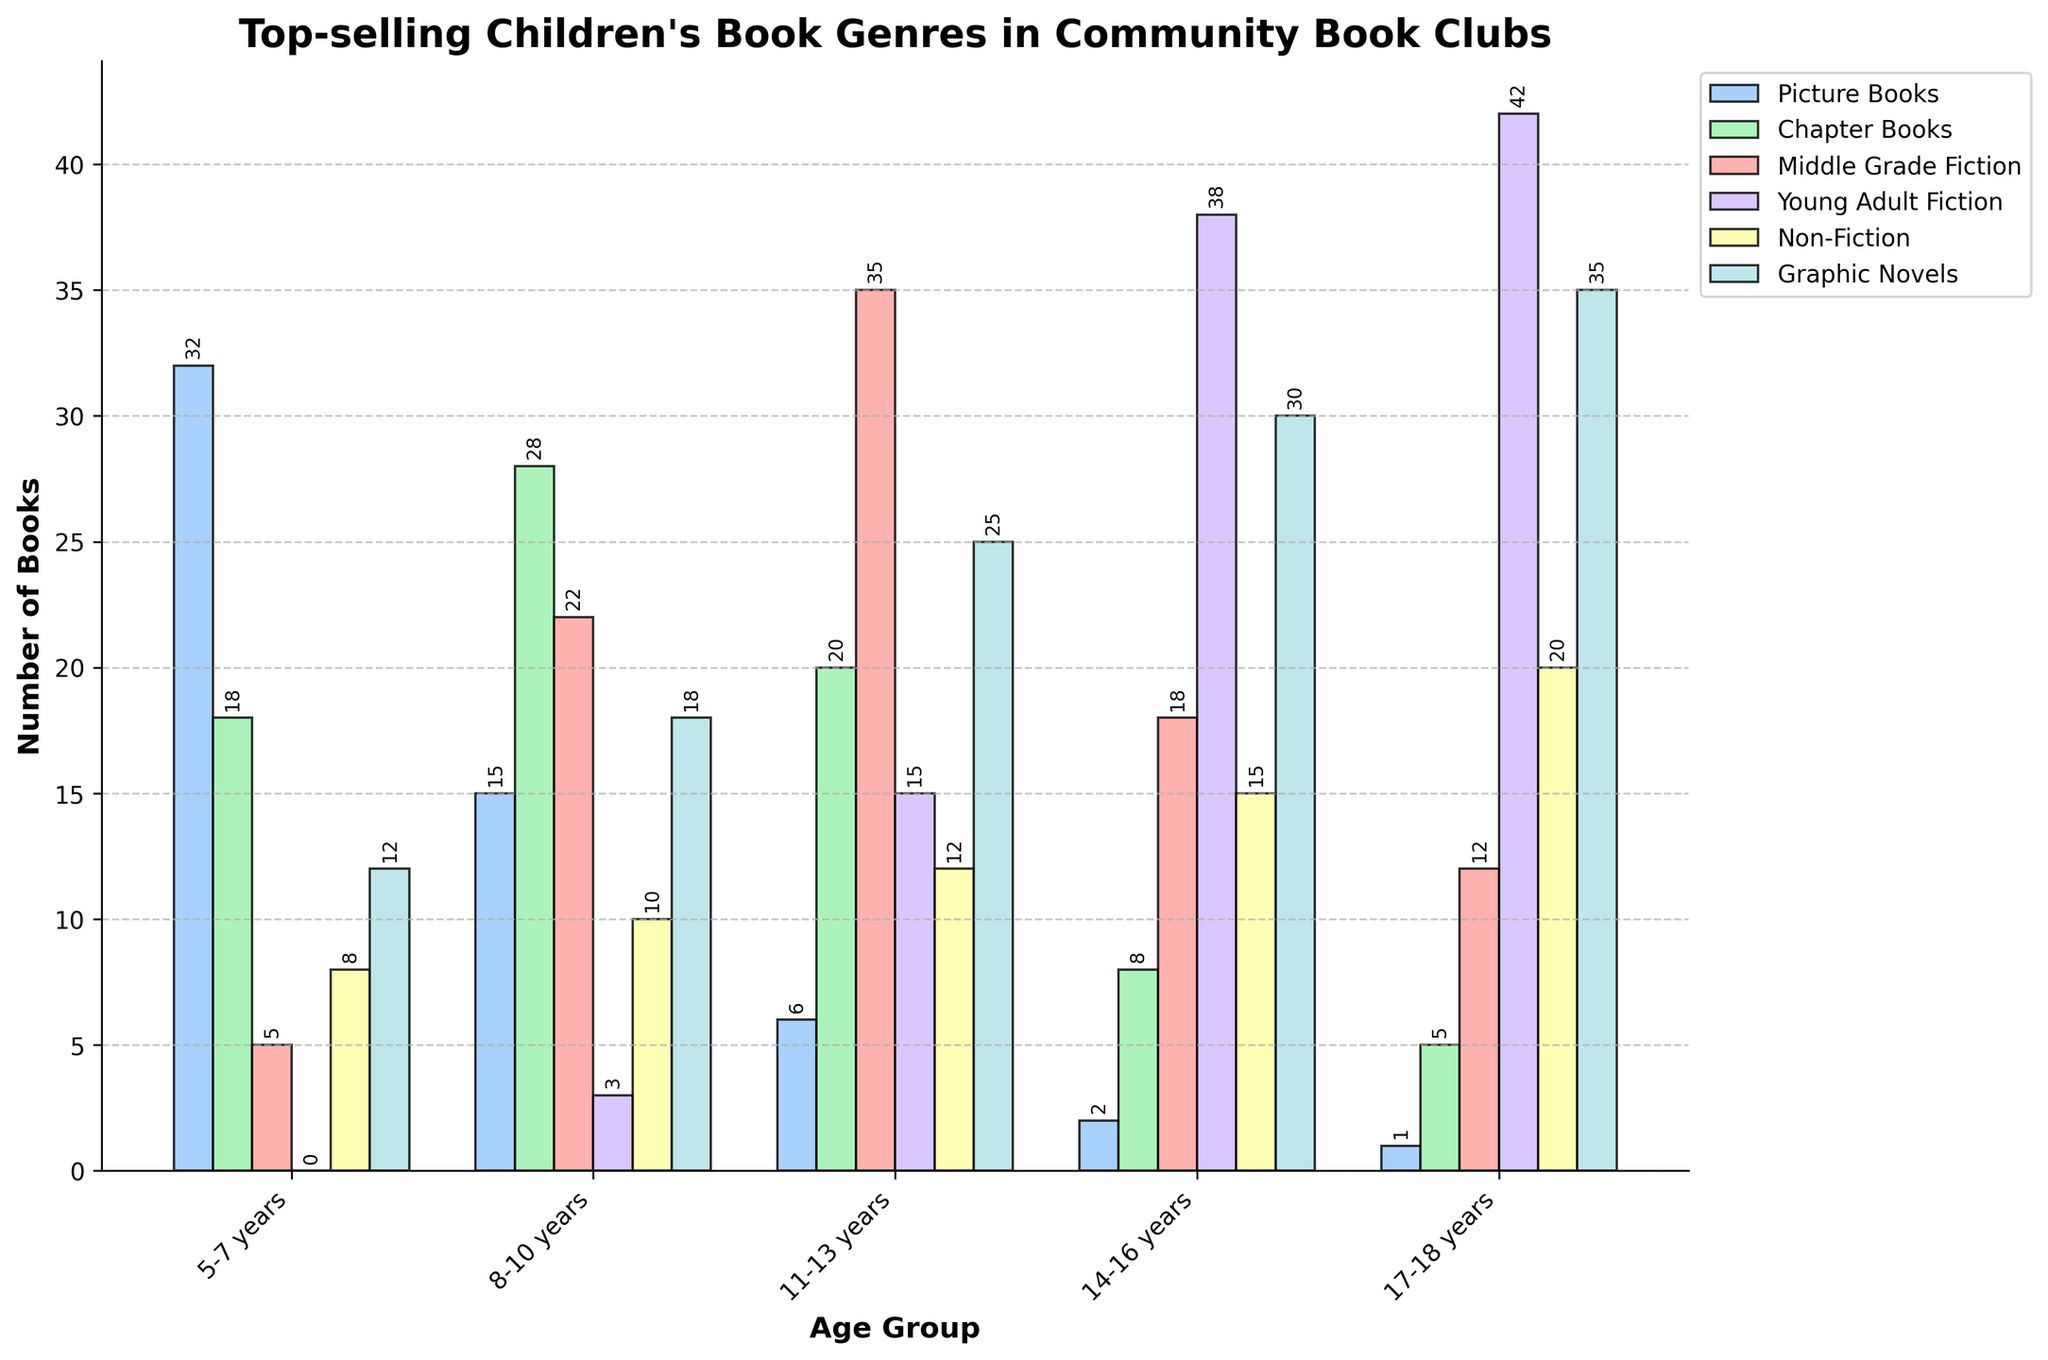What is the most popular genre among 11-13 years old? The bar labeled "Middle Grade Fiction" is the tallest for the age group 11-13 years, indicating it is the most popular genre in this group.
Answer: Middle Grade Fiction Which age group reads the most Non-Fiction books? Comparing the heights of the Non-Fiction bars across all age groups, the tallest bar is for the 17-18 years age group.
Answer: 17-18 years How many total books are read by the 14-16 years age group? Sum up the heights of all the bars for the 14-16 years age group: 2 (Picture Books) + 8 (Chapter Books) + 18 (Middle Grade Fiction) + 38 (Young Adult Fiction) + 15 (Non-Fiction) + 30 (Graphic Novels) = 111
Answer: 111 Which genre is equally popular across any two consecutive age groups? Comparing the bars for each genre, the height of the Non-Fiction bars for age groups 5-7 years (8) and 8-10 years (10) are close, but not equal. None of the genres has equal bar heights across two consecutive age groups.
Answer: None In which age group does Graphic Novels significantly outperform Picture Books? The significant difference is visually apparent in the 17-18 years age group where the height of Graphic Novels far exceeds the height of Picture Books (35 vs 1).
Answer: 17-18 years What is the difference in the number of Graphic Novels read by the 11-13 years and the 5-7 years age groups? The height of the Graphic Novels bar for the 11-13 years age group is 25, while for the 5-7 years, it is 12. The difference is 25 - 12 = 13.
Answer: 13 What is the sum of Chapter Books read by the 5-7 years and 14-16 years age groups? The height of Chapter Books for 5-7 years is 18, and for 14-16 years is 8. The sum is 18 + 8 = 26.
Answer: 26 Which genre shows a decreasing trend as age increases? Picture Books show a clear decrease in bar height as age increases from 5-7 years (32) to 17-18 years (1).
Answer: Picture Books 